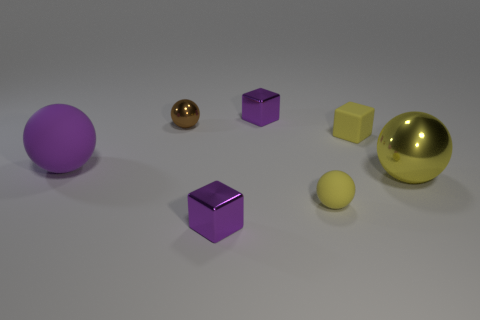Does the tiny brown object have the same material as the large yellow ball?
Give a very brief answer. Yes. There is a yellow rubber object that is the same shape as the large yellow metallic thing; what size is it?
Provide a short and direct response. Small. What number of objects are purple metallic objects in front of the large purple sphere or tiny purple blocks that are in front of the brown metallic ball?
Your answer should be compact. 1. Are there fewer matte blocks than purple shiny cubes?
Your answer should be very brief. Yes. Does the yellow shiny ball have the same size as the metallic block that is in front of the yellow matte sphere?
Your response must be concise. No. How many metal things are either small yellow cubes or small purple cylinders?
Provide a succinct answer. 0. Are there more large spheres than large blue metallic cylinders?
Offer a very short reply. Yes. There is a shiny sphere that is the same color as the matte block; what is its size?
Ensure brevity in your answer.  Large. There is a small yellow matte object that is in front of the big object in front of the big rubber object; what is its shape?
Give a very brief answer. Sphere. There is a purple metal cube in front of the large sphere to the right of the brown thing; are there any big purple objects that are right of it?
Provide a succinct answer. No. 